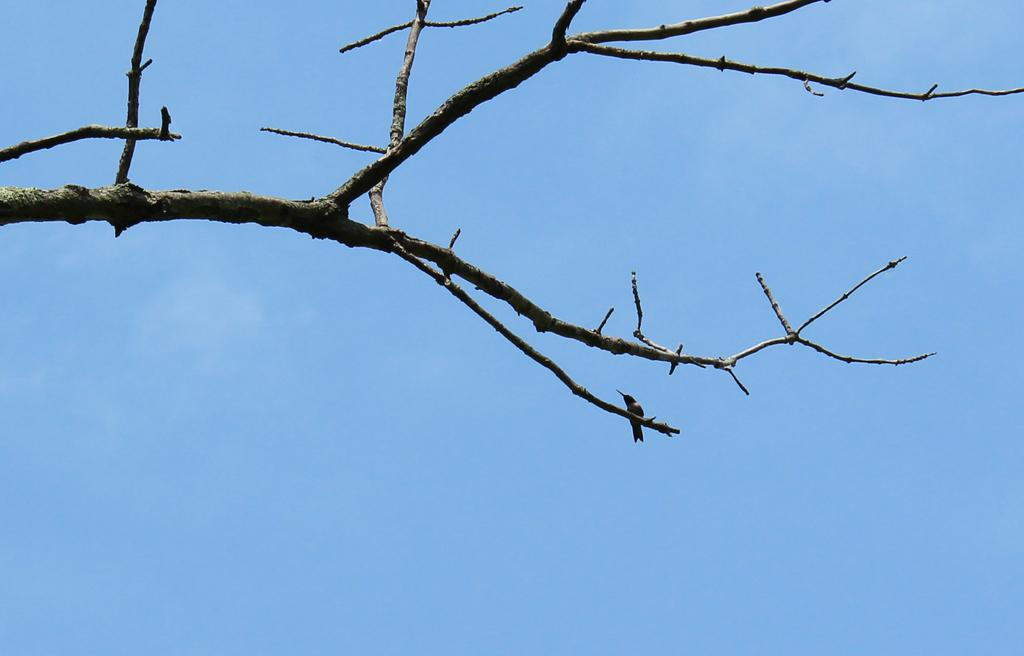What is the main object in the image? There is a branch in the image. What can be seen in the background of the image? The sky is visible in the background of the image. What type of development is taking place in the image? There is no development taking place in the image; it features a branch and the sky. Can you see any ghosts in the image? There are no ghosts present in the image. 